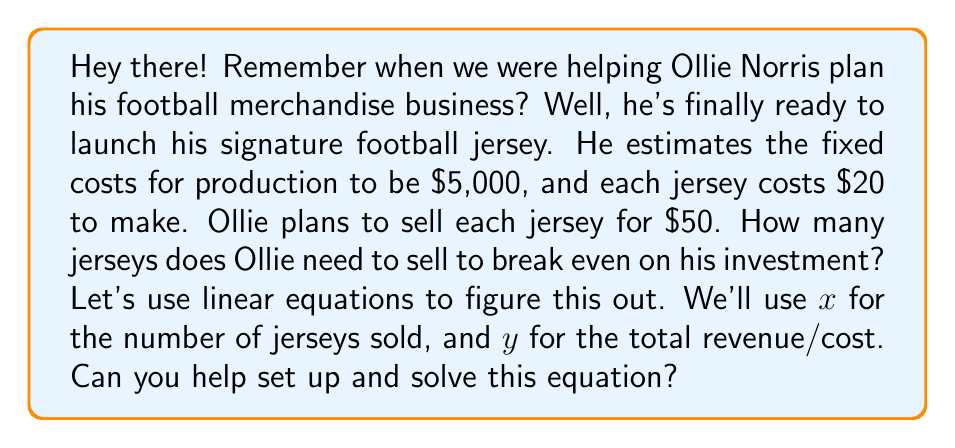Teach me how to tackle this problem. Certainly! Let's break this down step-by-step using linear equations:

1) First, let's define our variables:
   $x$ = number of jerseys sold
   $y$ = total revenue/cost

2) Now, let's set up two linear equations:

   Revenue equation: $y = 50x$ (Each jersey sells for $50)
   Cost equation: $y = 20x + 5000$ (Each jersey costs $20 to make, plus $5000 fixed costs)

3) At the break-even point, revenue equals cost. So we can set these equations equal to each other:

   $50x = 20x + 5000$

4) Now, let's solve this equation:
   $50x = 20x + 5000$
   $50x - 20x = 5000$
   $30x = 5000$

5) Divide both sides by 30:
   $x = 5000 / 30 = 166.67$

6) Since we can't sell a fraction of a jersey, we round up to the nearest whole number.

Therefore, Ollie needs to sell 167 jerseys to break even.

To verify:
Revenue: $167 * $50 = $8,350
Cost: $(167 * $20) + $5000 = $8,340

As we can see, at 167 jerseys, the revenue slightly exceeds the cost, confirming our break-even point.
Answer: Ollie needs to sell 167 jerseys to break even. 